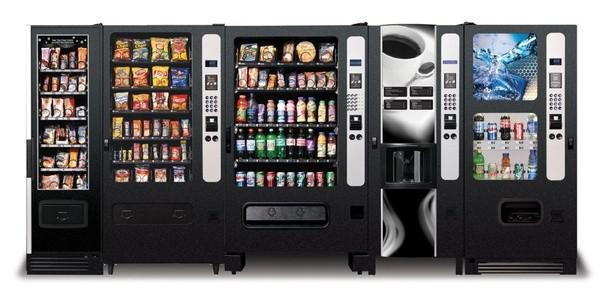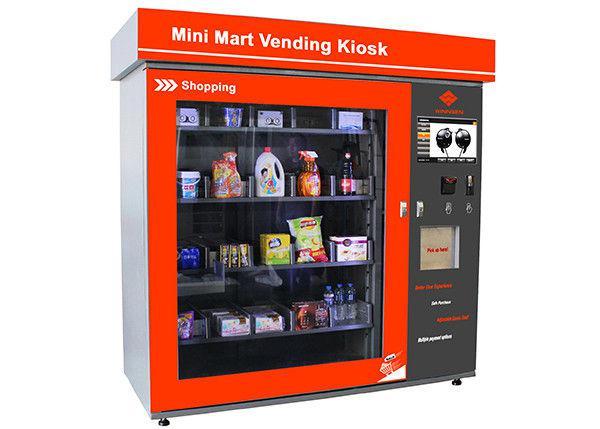The first image is the image on the left, the second image is the image on the right. Evaluate the accuracy of this statement regarding the images: "There is exactly one vending machine in the image on the right.". Is it true? Answer yes or no. Yes. 